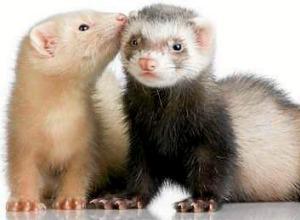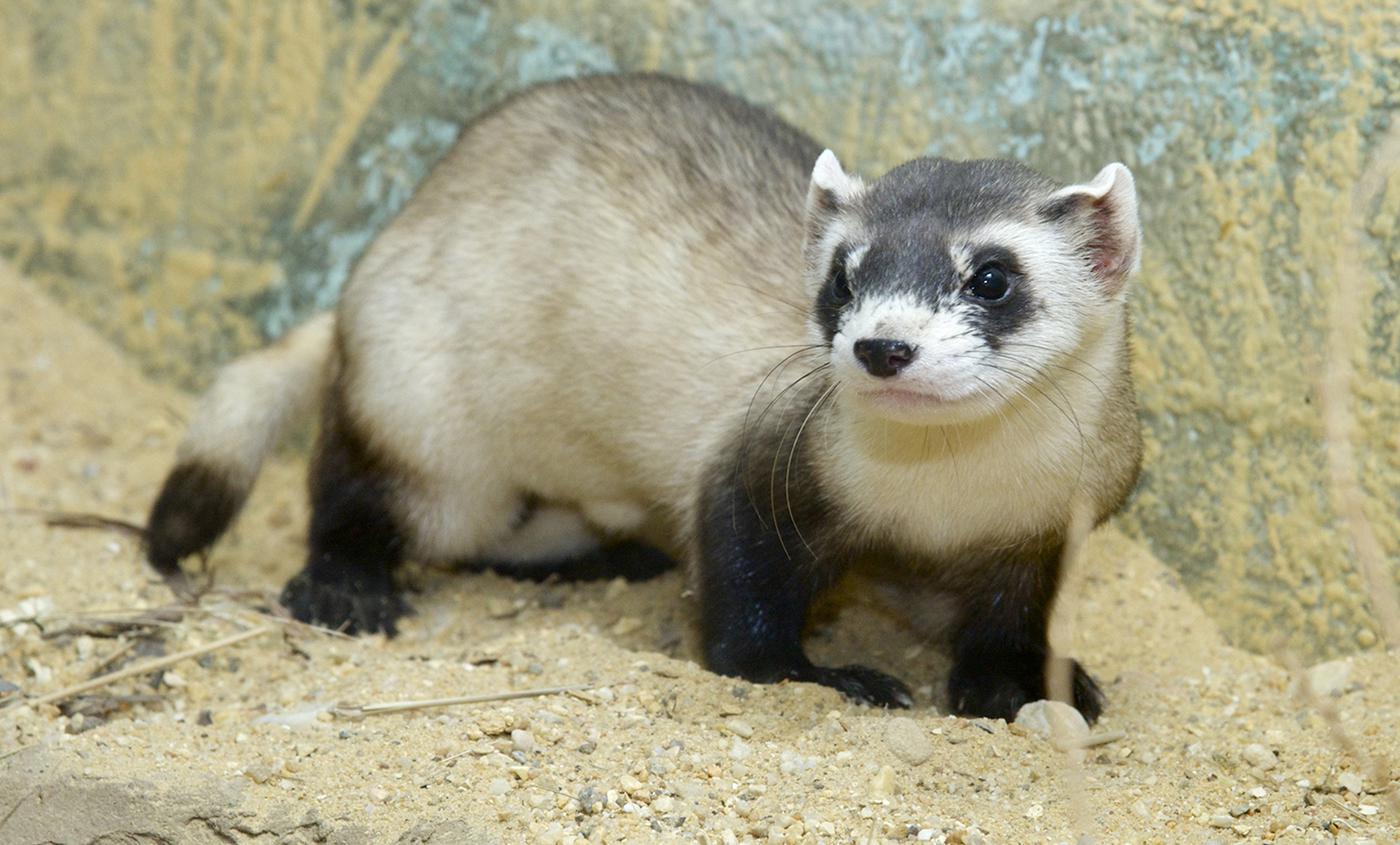The first image is the image on the left, the second image is the image on the right. Evaluate the accuracy of this statement regarding the images: "There are three ferrets in one of the images.". Is it true? Answer yes or no. No. The first image is the image on the left, the second image is the image on the right. Analyze the images presented: Is the assertion "There are at most 3 ferretts in the image pair." valid? Answer yes or no. Yes. 